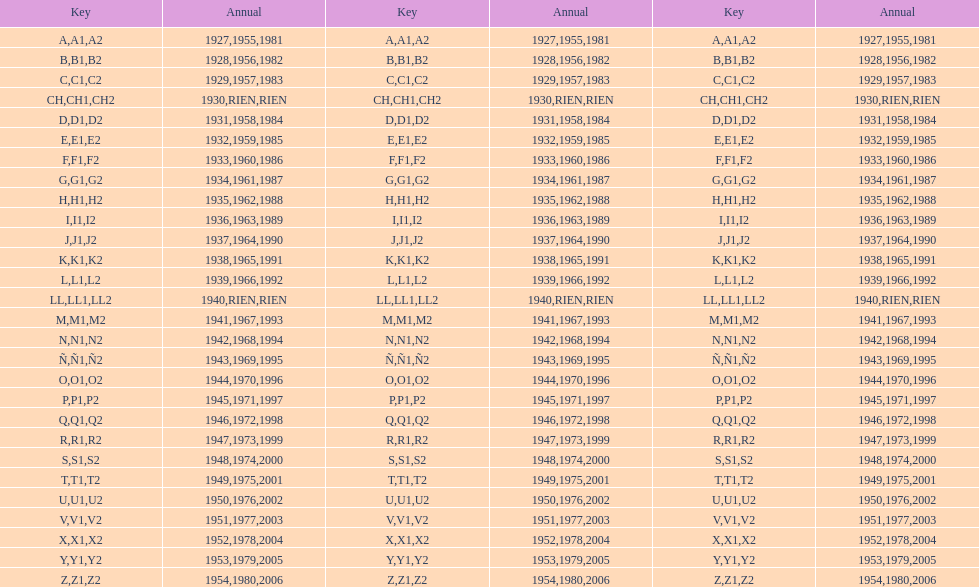Number of codes containing a 2? 28. 